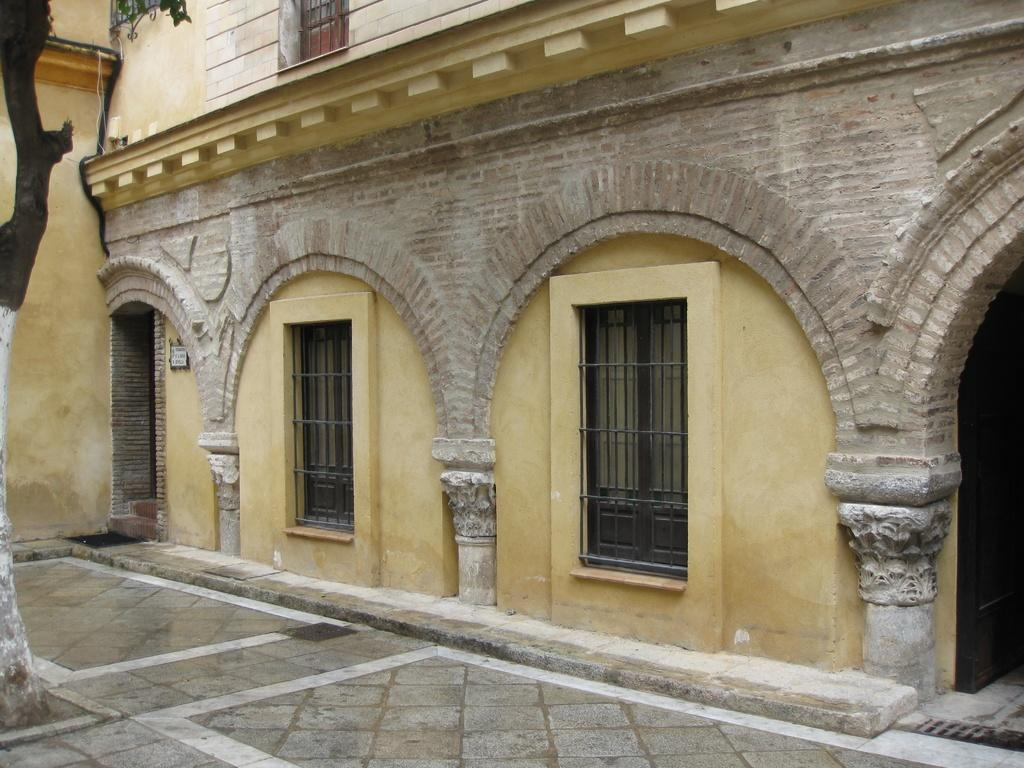What is located in the center of the image? There are windows and a building in the center of the image. Can you describe the windows in the image? The windows are in the center of the image, but their specific characteristics are not mentioned in the provided facts. What type of structure is depicted in the image? There is a building in the center of the image. What color is the flag flying on top of the building in the image? There is no flag visible in the image, so we cannot determine its color. What part of the building is shown in the image? The provided facts only mention that there is a building in the center of the image, but they do not specify which part of the building is visible. 